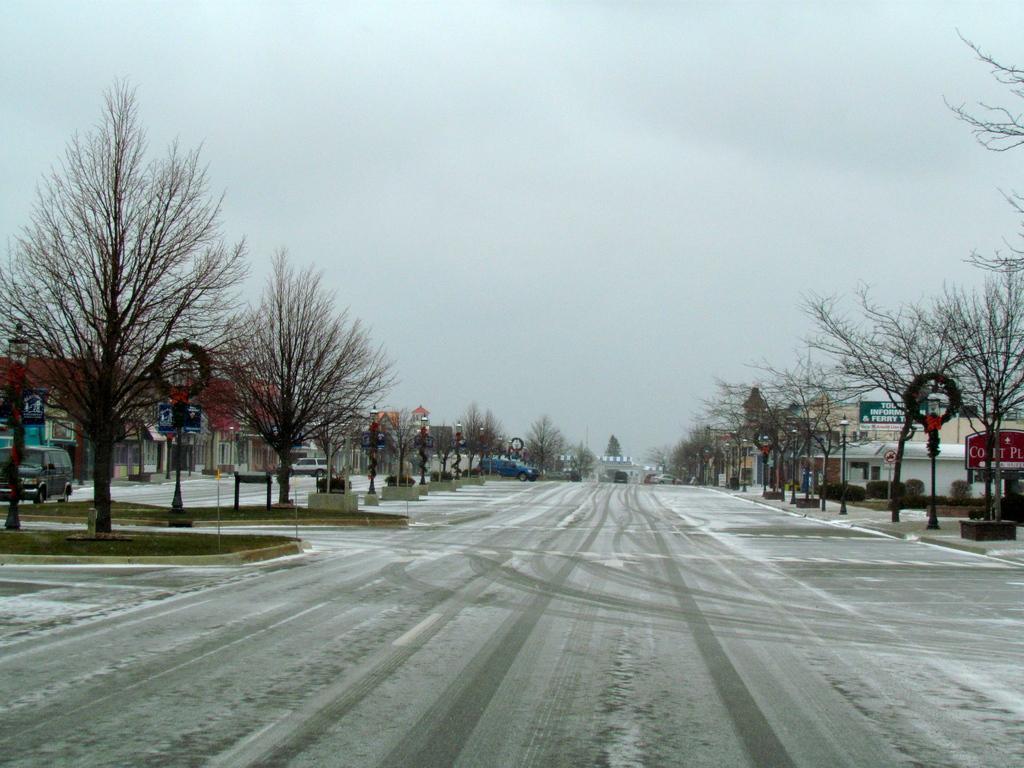How would you summarize this image in a sentence or two? At the bottom we can see snow on the road and on the left side there are bare trees,buildings,vehicles on the road and in the middle there are vehicles on the road,trees and on the right side there are buildings,poles,boards,bare trees. In the background there is a sky. 